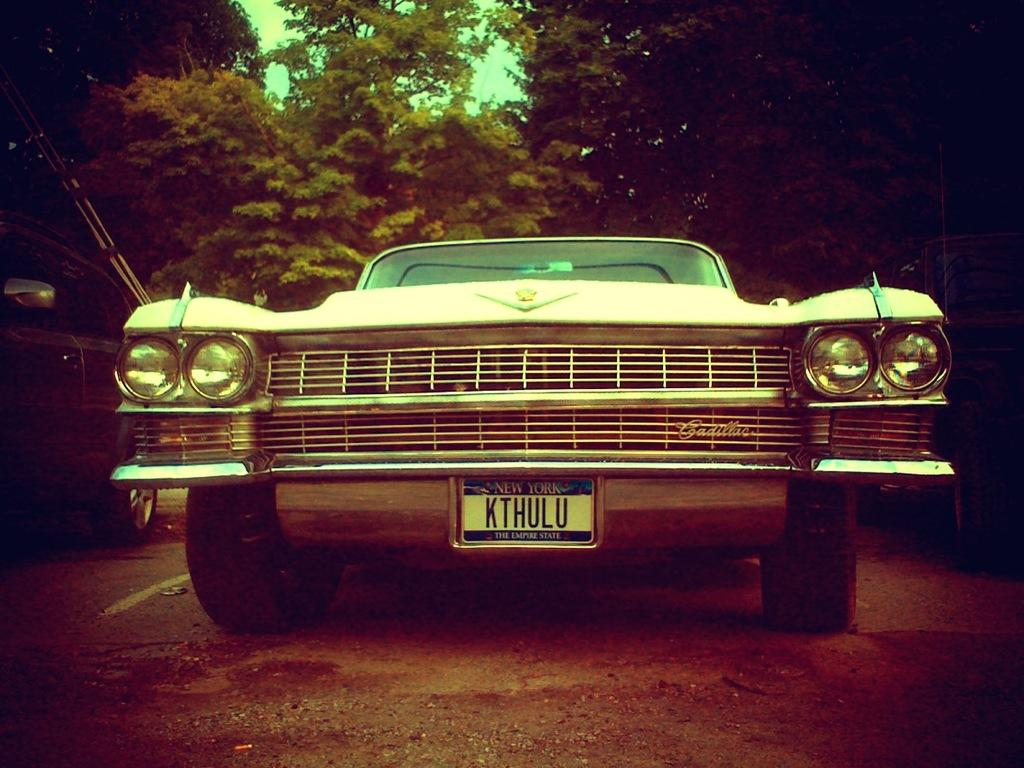What is the main subject of the image? The main subject of the image is a car. Where is the car located in the image? The car is on a road in the image. What can be seen in the background of the image? There are trees in the background of the image. What type of oatmeal is being served in the car? There is no oatmeal present in the image; it only features a car on a road with trees in the background. 